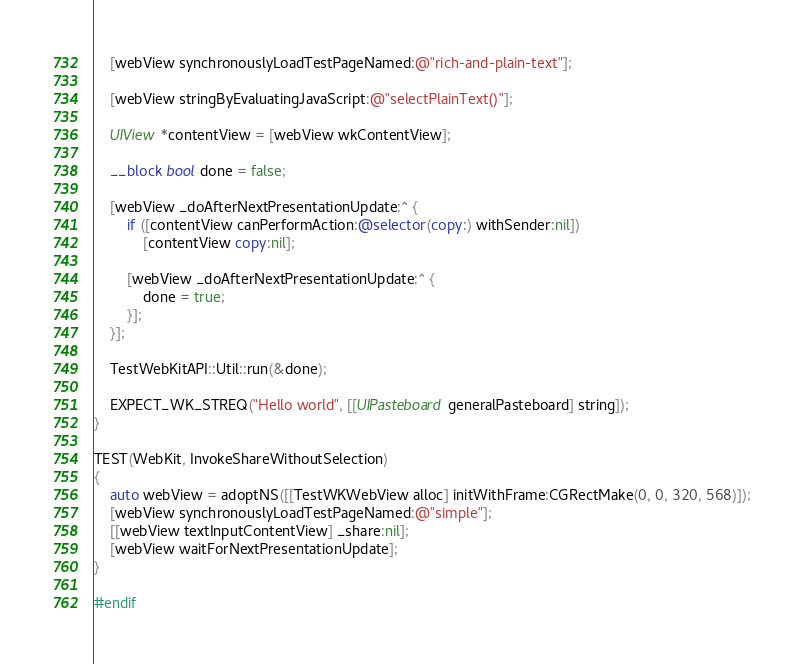Convert code to text. <code><loc_0><loc_0><loc_500><loc_500><_ObjectiveC_>
    [webView synchronouslyLoadTestPageNamed:@"rich-and-plain-text"];

    [webView stringByEvaluatingJavaScript:@"selectPlainText()"];

    UIView *contentView = [webView wkContentView];

    __block bool done = false;

    [webView _doAfterNextPresentationUpdate:^ {
        if ([contentView canPerformAction:@selector(copy:) withSender:nil])
            [contentView copy:nil];

        [webView _doAfterNextPresentationUpdate:^ {
            done = true;
        }];
    }];

    TestWebKitAPI::Util::run(&done);

    EXPECT_WK_STREQ("Hello world", [[UIPasteboard generalPasteboard] string]);
}

TEST(WebKit, InvokeShareWithoutSelection)
{
    auto webView = adoptNS([[TestWKWebView alloc] initWithFrame:CGRectMake(0, 0, 320, 568)]);
    [webView synchronouslyLoadTestPageNamed:@"simple"];
    [[webView textInputContentView] _share:nil];
    [webView waitForNextPresentationUpdate];
}

#endif
</code> 